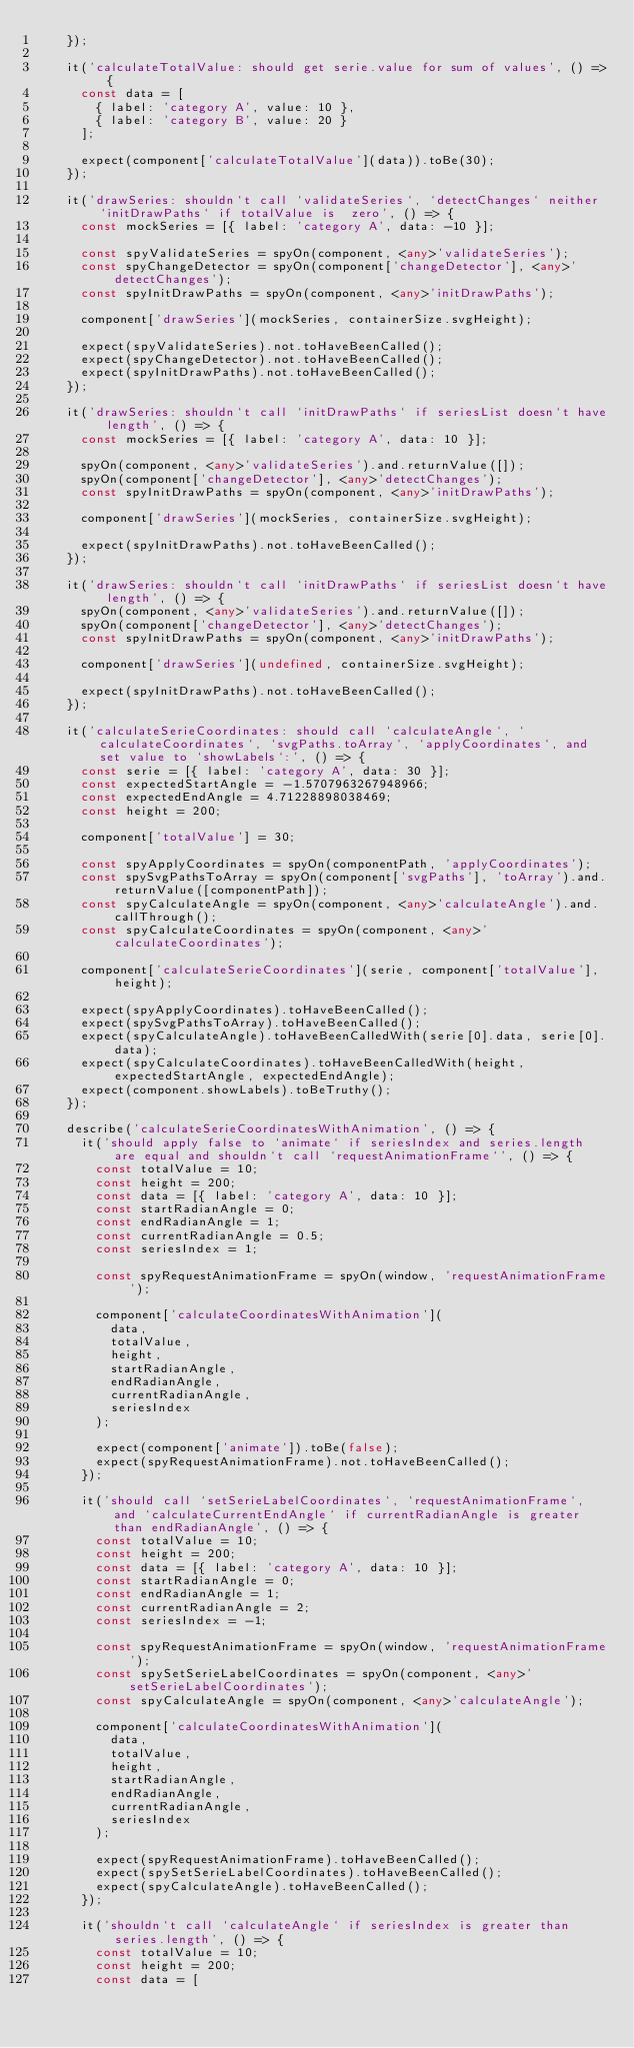<code> <loc_0><loc_0><loc_500><loc_500><_TypeScript_>    });

    it('calculateTotalValue: should get serie.value for sum of values', () => {
      const data = [
        { label: 'category A', value: 10 },
        { label: 'category B', value: 20 }
      ];

      expect(component['calculateTotalValue'](data)).toBe(30);
    });

    it('drawSeries: shouldn`t call `validateSeries`, `detectChanges` neither `initDrawPaths` if totalValue is  zero', () => {
      const mockSeries = [{ label: 'category A', data: -10 }];

      const spyValidateSeries = spyOn(component, <any>'validateSeries');
      const spyChangeDetector = spyOn(component['changeDetector'], <any>'detectChanges');
      const spyInitDrawPaths = spyOn(component, <any>'initDrawPaths');

      component['drawSeries'](mockSeries, containerSize.svgHeight);

      expect(spyValidateSeries).not.toHaveBeenCalled();
      expect(spyChangeDetector).not.toHaveBeenCalled();
      expect(spyInitDrawPaths).not.toHaveBeenCalled();
    });

    it('drawSeries: shouldn`t call `initDrawPaths` if seriesList doesn`t have length', () => {
      const mockSeries = [{ label: 'category A', data: 10 }];

      spyOn(component, <any>'validateSeries').and.returnValue([]);
      spyOn(component['changeDetector'], <any>'detectChanges');
      const spyInitDrawPaths = spyOn(component, <any>'initDrawPaths');

      component['drawSeries'](mockSeries, containerSize.svgHeight);

      expect(spyInitDrawPaths).not.toHaveBeenCalled();
    });

    it('drawSeries: shouldn`t call `initDrawPaths` if seriesList doesn`t have length', () => {
      spyOn(component, <any>'validateSeries').and.returnValue([]);
      spyOn(component['changeDetector'], <any>'detectChanges');
      const spyInitDrawPaths = spyOn(component, <any>'initDrawPaths');

      component['drawSeries'](undefined, containerSize.svgHeight);

      expect(spyInitDrawPaths).not.toHaveBeenCalled();
    });

    it('calculateSerieCoordinates: should call `calculateAngle`, `calculateCoordinates`, `svgPaths.toArray`, `applyCoordinates`, and set value to `showLabels`:', () => {
      const serie = [{ label: 'category A', data: 30 }];
      const expectedStartAngle = -1.5707963267948966;
      const expectedEndAngle = 4.71228898038469;
      const height = 200;

      component['totalValue'] = 30;

      const spyApplyCoordinates = spyOn(componentPath, 'applyCoordinates');
      const spySvgPathsToArray = spyOn(component['svgPaths'], 'toArray').and.returnValue([componentPath]);
      const spyCalculateAngle = spyOn(component, <any>'calculateAngle').and.callThrough();
      const spyCalculateCoordinates = spyOn(component, <any>'calculateCoordinates');

      component['calculateSerieCoordinates'](serie, component['totalValue'], height);

      expect(spyApplyCoordinates).toHaveBeenCalled();
      expect(spySvgPathsToArray).toHaveBeenCalled();
      expect(spyCalculateAngle).toHaveBeenCalledWith(serie[0].data, serie[0].data);
      expect(spyCalculateCoordinates).toHaveBeenCalledWith(height, expectedStartAngle, expectedEndAngle);
      expect(component.showLabels).toBeTruthy();
    });

    describe('calculateSerieCoordinatesWithAnimation', () => {
      it('should apply false to `animate` if seriesIndex and series.length are equal and shouldn`t call `requestAnimationFrame`', () => {
        const totalValue = 10;
        const height = 200;
        const data = [{ label: 'category A', data: 10 }];
        const startRadianAngle = 0;
        const endRadianAngle = 1;
        const currentRadianAngle = 0.5;
        const seriesIndex = 1;

        const spyRequestAnimationFrame = spyOn(window, 'requestAnimationFrame');

        component['calculateCoordinatesWithAnimation'](
          data,
          totalValue,
          height,
          startRadianAngle,
          endRadianAngle,
          currentRadianAngle,
          seriesIndex
        );

        expect(component['animate']).toBe(false);
        expect(spyRequestAnimationFrame).not.toHaveBeenCalled();
      });

      it('should call `setSerieLabelCoordinates`, `requestAnimationFrame`, and `calculateCurrentEndAngle` if currentRadianAngle is greater than endRadianAngle', () => {
        const totalValue = 10;
        const height = 200;
        const data = [{ label: 'category A', data: 10 }];
        const startRadianAngle = 0;
        const endRadianAngle = 1;
        const currentRadianAngle = 2;
        const seriesIndex = -1;

        const spyRequestAnimationFrame = spyOn(window, 'requestAnimationFrame');
        const spySetSerieLabelCoordinates = spyOn(component, <any>'setSerieLabelCoordinates');
        const spyCalculateAngle = spyOn(component, <any>'calculateAngle');

        component['calculateCoordinatesWithAnimation'](
          data,
          totalValue,
          height,
          startRadianAngle,
          endRadianAngle,
          currentRadianAngle,
          seriesIndex
        );

        expect(spyRequestAnimationFrame).toHaveBeenCalled();
        expect(spySetSerieLabelCoordinates).toHaveBeenCalled();
        expect(spyCalculateAngle).toHaveBeenCalled();
      });

      it('shouldn`t call `calculateAngle` if seriesIndex is greater than series.length', () => {
        const totalValue = 10;
        const height = 200;
        const data = [</code> 